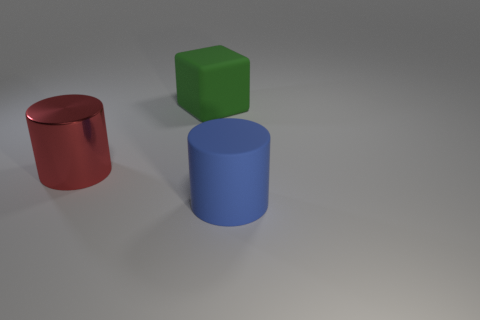There is a cylinder that is in front of the red object; what is its material?
Make the answer very short. Rubber. Is there any other thing that is the same color as the metallic object?
Offer a terse response. No. What is the size of the green thing that is the same material as the blue cylinder?
Make the answer very short. Large. How many small objects are either green rubber balls or cubes?
Your answer should be compact. 0. How big is the thing in front of the thing on the left side of the large thing behind the red cylinder?
Provide a short and direct response. Large. How many rubber cylinders have the same size as the green matte block?
Keep it short and to the point. 1. How many objects are either tiny green rubber spheres or objects that are in front of the matte block?
Offer a terse response. 2. There is a green thing; what shape is it?
Give a very brief answer. Cube. Do the metal cylinder and the big block have the same color?
Offer a terse response. No. There is a shiny object that is the same size as the rubber cylinder; what is its color?
Your answer should be compact. Red. 